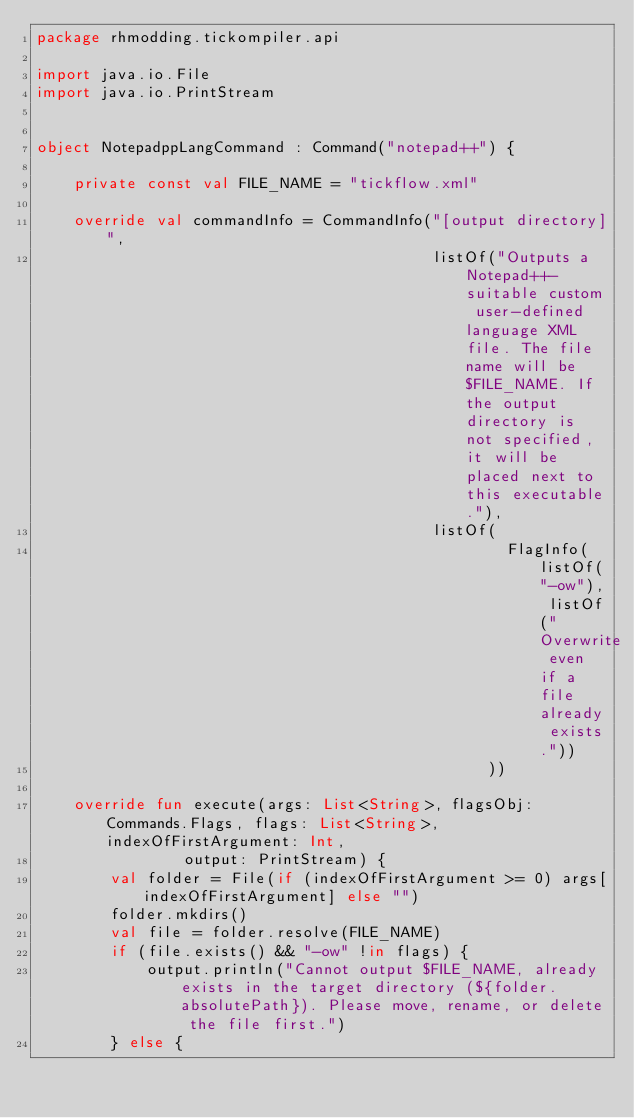Convert code to text. <code><loc_0><loc_0><loc_500><loc_500><_Kotlin_>package rhmodding.tickompiler.api

import java.io.File
import java.io.PrintStream


object NotepadppLangCommand : Command("notepad++") {

    private const val FILE_NAME = "tickflow.xml"

    override val commandInfo = CommandInfo("[output directory]",
                                           listOf("Outputs a Notepad++-suitable custom user-defined language XML file. The file name will be $FILE_NAME. If the output directory is not specified, it will be placed next to this executable."),
                                           listOf(
                                                   FlagInfo(listOf("-ow"), listOf("Overwrite even if a file already exists."))
                                                 ))

    override fun execute(args: List<String>, flagsObj: Commands.Flags, flags: List<String>, indexOfFirstArgument: Int,
                output: PrintStream) {
        val folder = File(if (indexOfFirstArgument >= 0) args[indexOfFirstArgument] else "")
        folder.mkdirs()
        val file = folder.resolve(FILE_NAME)
        if (file.exists() && "-ow" !in flags) {
            output.println("Cannot output $FILE_NAME, already exists in the target directory (${folder.absolutePath}). Please move, rename, or delete the file first.")
        } else {</code> 